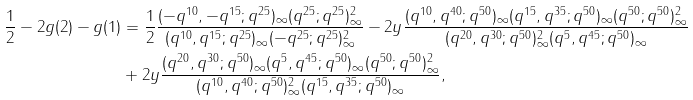Convert formula to latex. <formula><loc_0><loc_0><loc_500><loc_500>\frac { 1 } { 2 } - 2 g ( 2 ) - g ( 1 ) & = \frac { 1 } { 2 } \frac { ( - q ^ { 1 0 } , - q ^ { 1 5 } ; q ^ { 2 5 } ) _ { \infty } ( q ^ { 2 5 } ; q ^ { 2 5 } ) _ { \infty } ^ { 2 } } { ( q ^ { 1 0 } , q ^ { 1 5 } ; q ^ { 2 5 } ) _ { \infty } ( - q ^ { 2 5 } ; q ^ { 2 5 } ) _ { \infty } ^ { 2 } } - 2 y \frac { ( q ^ { 1 0 } , q ^ { 4 0 } ; q ^ { 5 0 } ) _ { \infty } ( q ^ { 1 5 } , q ^ { 3 5 } ; q ^ { 5 0 } ) _ { \infty } ( q ^ { 5 0 } ; q ^ { 5 0 } ) _ { \infty } ^ { 2 } } { ( q ^ { 2 0 } , q ^ { 3 0 } ; q ^ { 5 0 } ) _ { \infty } ^ { 2 } ( q ^ { 5 } , q ^ { 4 5 } ; q ^ { 5 0 } ) _ { \infty } } \\ & + 2 y \frac { ( q ^ { 2 0 } , q ^ { 3 0 } ; q ^ { 5 0 } ) _ { \infty } ( q ^ { 5 } , q ^ { 4 5 } ; q ^ { 5 0 } ) _ { \infty } ( q ^ { 5 0 } ; q ^ { 5 0 } ) _ { \infty } ^ { 2 } } { ( q ^ { 1 0 } , q ^ { 4 0 } ; q ^ { 5 0 } ) _ { \infty } ^ { 2 } ( q ^ { 1 5 } , q ^ { 3 5 } ; q ^ { 5 0 } ) _ { \infty } } ,</formula> 